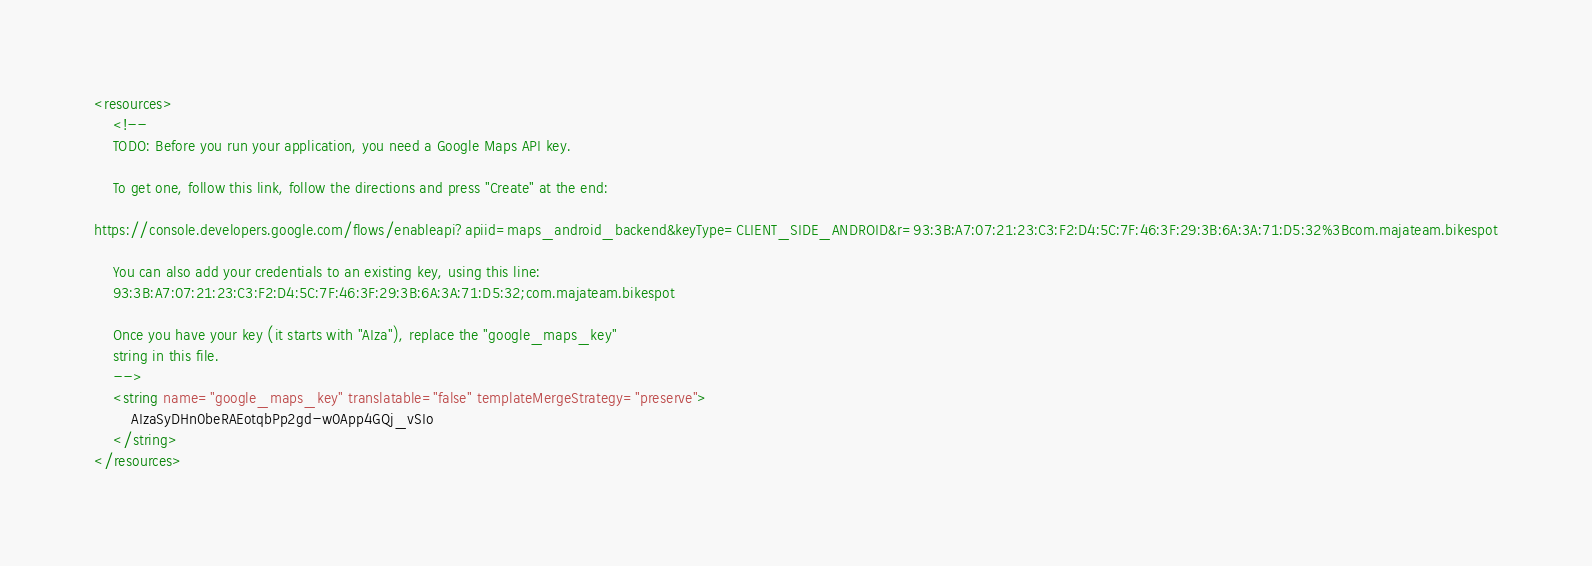<code> <loc_0><loc_0><loc_500><loc_500><_XML_><resources>
    <!--
    TODO: Before you run your application, you need a Google Maps API key.

    To get one, follow this link, follow the directions and press "Create" at the end:

https://console.developers.google.com/flows/enableapi?apiid=maps_android_backend&keyType=CLIENT_SIDE_ANDROID&r=93:3B:A7:07:21:23:C3:F2:D4:5C:7F:46:3F:29:3B:6A:3A:71:D5:32%3Bcom.majateam.bikespot

    You can also add your credentials to an existing key, using this line:
    93:3B:A7:07:21:23:C3:F2:D4:5C:7F:46:3F:29:3B:6A:3A:71:D5:32;com.majateam.bikespot

    Once you have your key (it starts with "AIza"), replace the "google_maps_key"
    string in this file.
    -->
    <string name="google_maps_key" translatable="false" templateMergeStrategy="preserve">
        AIzaSyDHn0beRAEotqbPp2gd-w0App4GQj_vSIo
    </string>
</resources>
</code> 